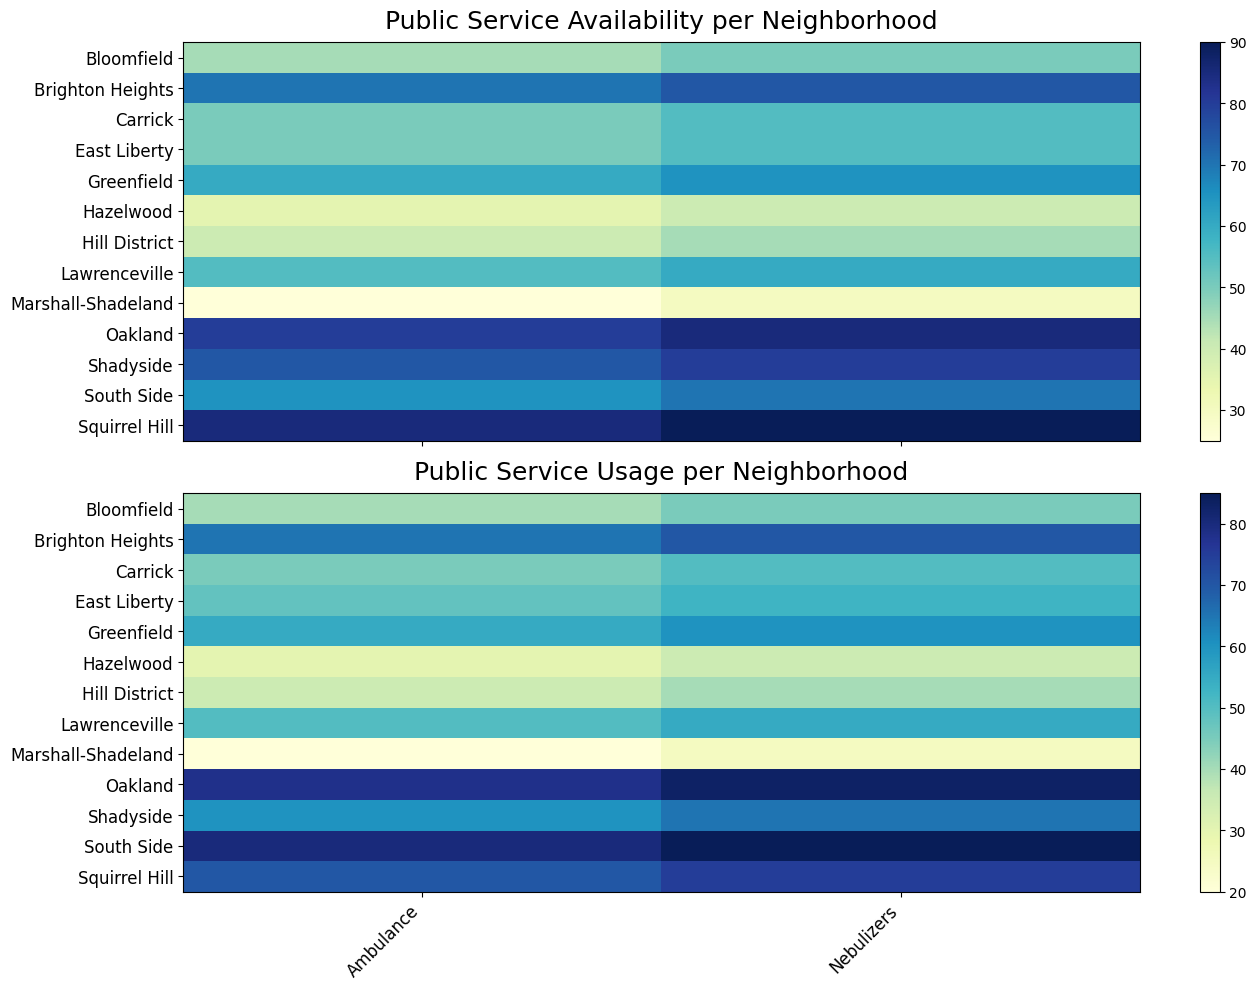How does the availability score for nebulizers in Squirrel Hill compare to the South Side? By looking at the colors corresponding to nebulizers in Squirrel Hill and the South Side on the availability heatmap, we notice that the hue in Squirrel Hill is considerably darker, indicating a higher score. To quantify, Squirrel Hill has a score of 90, while the South Side has a score of 70.
Answer: Squirrel Hill has a higher score Which neighborhood has the highest usage score for ambulances? We can identify the neighborhood with the highest ambulance usage score by finding the darkest cell in the Ambulance column on the usage heatmap. Oakland has the darkest shade indicating the highest score of 78.
Answer: Oakland Which neighborhood has the biggest difference in availability and usage scores for nebulizers? By computing the differences for each neighborhood: Squirrel Hill (90-75=15), Shadyside (80-65=15), South Side (70-85=-15), Lawrenceville (60-55=5), Bloomfield (50-45=5), Oakland (85-83=2), Hill District (45-40=5), East Liberty (55-53=2), Greenfield (65-60=5), Hazelwood (40-35=5), Brighton Heights (75-70=5), Carrick (55-50=5), Marshall-Shadeland (30-25=5). The highest difference is from South Side with 15.
Answer: South Side What's the average availability score of all public services in Bloomfield? For Bloomfield, the availability scores are 50 (nebulizers) and 45 (ambulance). Averaging these: (50 + 45) / 2 = 47.5.
Answer: 47.5 Is the average usage score for public services higher or lower than the average availability score in East Liberty? First, calculate the averages: Availability scores in East Liberty: (55 + 50) / 2 = 52.5; Usage scores: (53 + 48) / 2 = 50.5. Comparing the two, the usage score average (50.5) is lower than the availability score average (52.5).
Answer: Lower Which public service shows a higher variability in usage across neighborhoods? By visually comparing the range of colors for both public services on the usage heatmap, we observe wider color variation in nebulizers compared to ambulances, indicating higher variability.
Answer: Nebulizers How does the lightness of Hazelwood's availability heatmap cells for public services relate to its usage heatmap cells? On both heatmaps, Hazelwood's cells' colors for public services are among the lightest shades on the charts, suggesting low scores for both availability and usage.
Answer: Similar and light What is the total usage score for all public services in Shadyside? Sum the usage scores for Shadyside: Nebulizers (65) + Ambulance (60) = 125.
Answer: 125 Which neighborhood has the smallest differential between availability and usage scores for ambulances? By calculating the differences: Squirrel Hill (85-70=15), Shadyside (75-60=15), South Side (65-80=-15), Lawrenceville (55-50=5), Bloomfield (45-40=5), Oakland (80-78=2), Hill District (40-35=5), East Liberty (50-48=2), Greenfield (60-55=5), Hazelwood (35-30=5), Brighton Heights (70-65=5), Carrick (50-45=5), Marshall-Shadeland (25-20=5). Oakland and East Liberty have the smallest differential of 2.
Answer: Oakland and East Liberty What is the most frequent score range for ambulance usage across all neighborhoods? Observing the heatmap, most cells in the ambulance usage column appear in the middle hues, suggesting scores generally fall between 35-70.
Answer: 35-70 